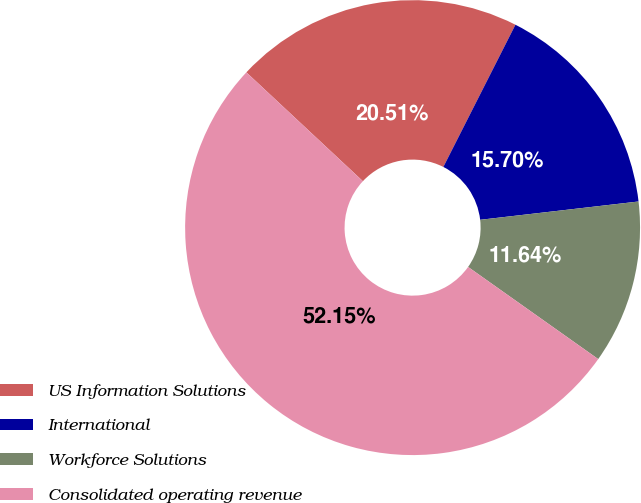Convert chart. <chart><loc_0><loc_0><loc_500><loc_500><pie_chart><fcel>US Information Solutions<fcel>International<fcel>Workforce Solutions<fcel>Consolidated operating revenue<nl><fcel>20.51%<fcel>15.7%<fcel>11.64%<fcel>52.15%<nl></chart> 